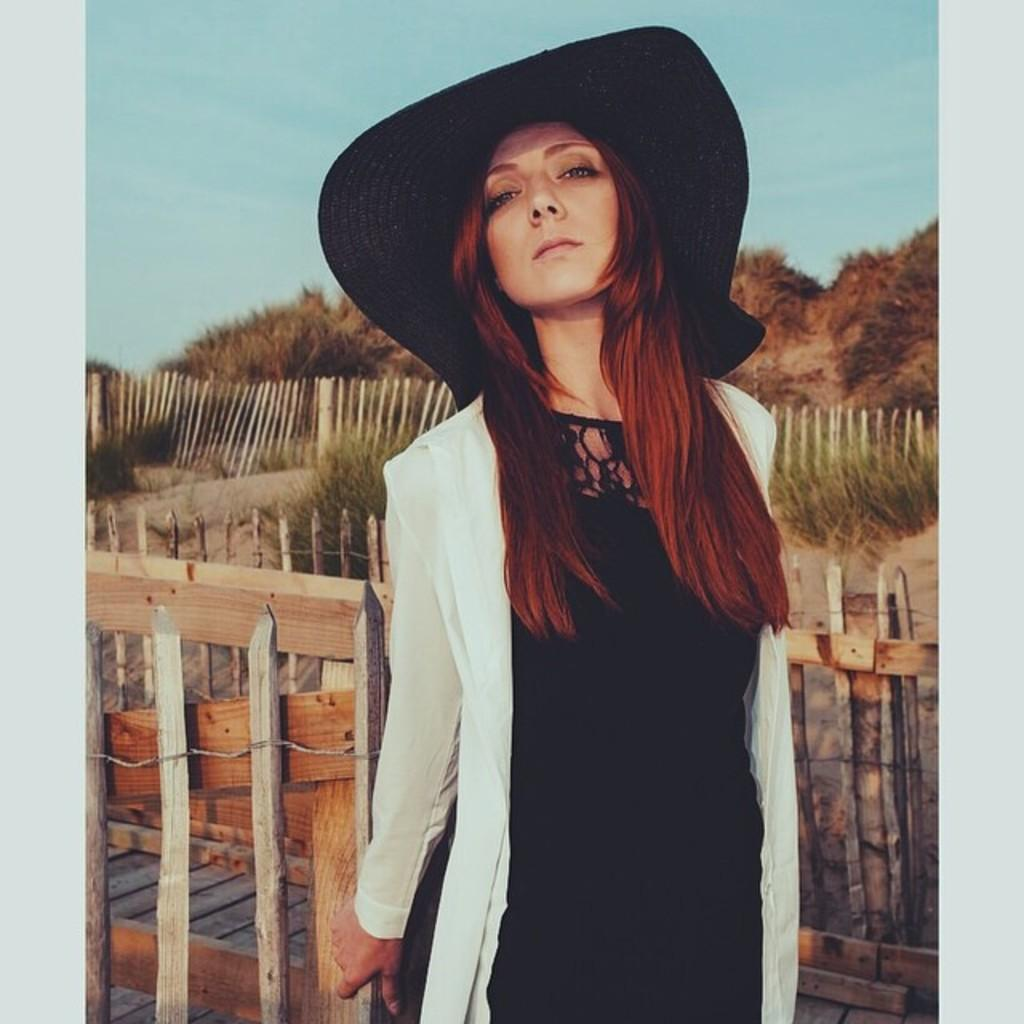Who is present in the image? There is a woman in the image. What is the woman wearing on her head? The woman is wearing a hat. What type of clothing is the woman wearing? The woman is wearing a dress. What surface is the woman standing on? The woman is standing on the floor. What can be seen in the background of the image? There is a wooden fence, a group of plants, and the sky visible in the background of the image. What type of account does the woman have with the airline in the image? There is no reference to an airline or any accounts in the image, so it is not possible to answer that question. 